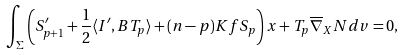Convert formula to latex. <formula><loc_0><loc_0><loc_500><loc_500>\int _ { \Sigma } \left ( S ^ { \prime } _ { p + 1 } + \frac { 1 } { 2 } \langle I ^ { \prime } , B T _ { p } \rangle + ( n - p ) K f S _ { p } \right ) x + T _ { p } \overline { \nabla } _ { X } N d v = 0 ,</formula> 